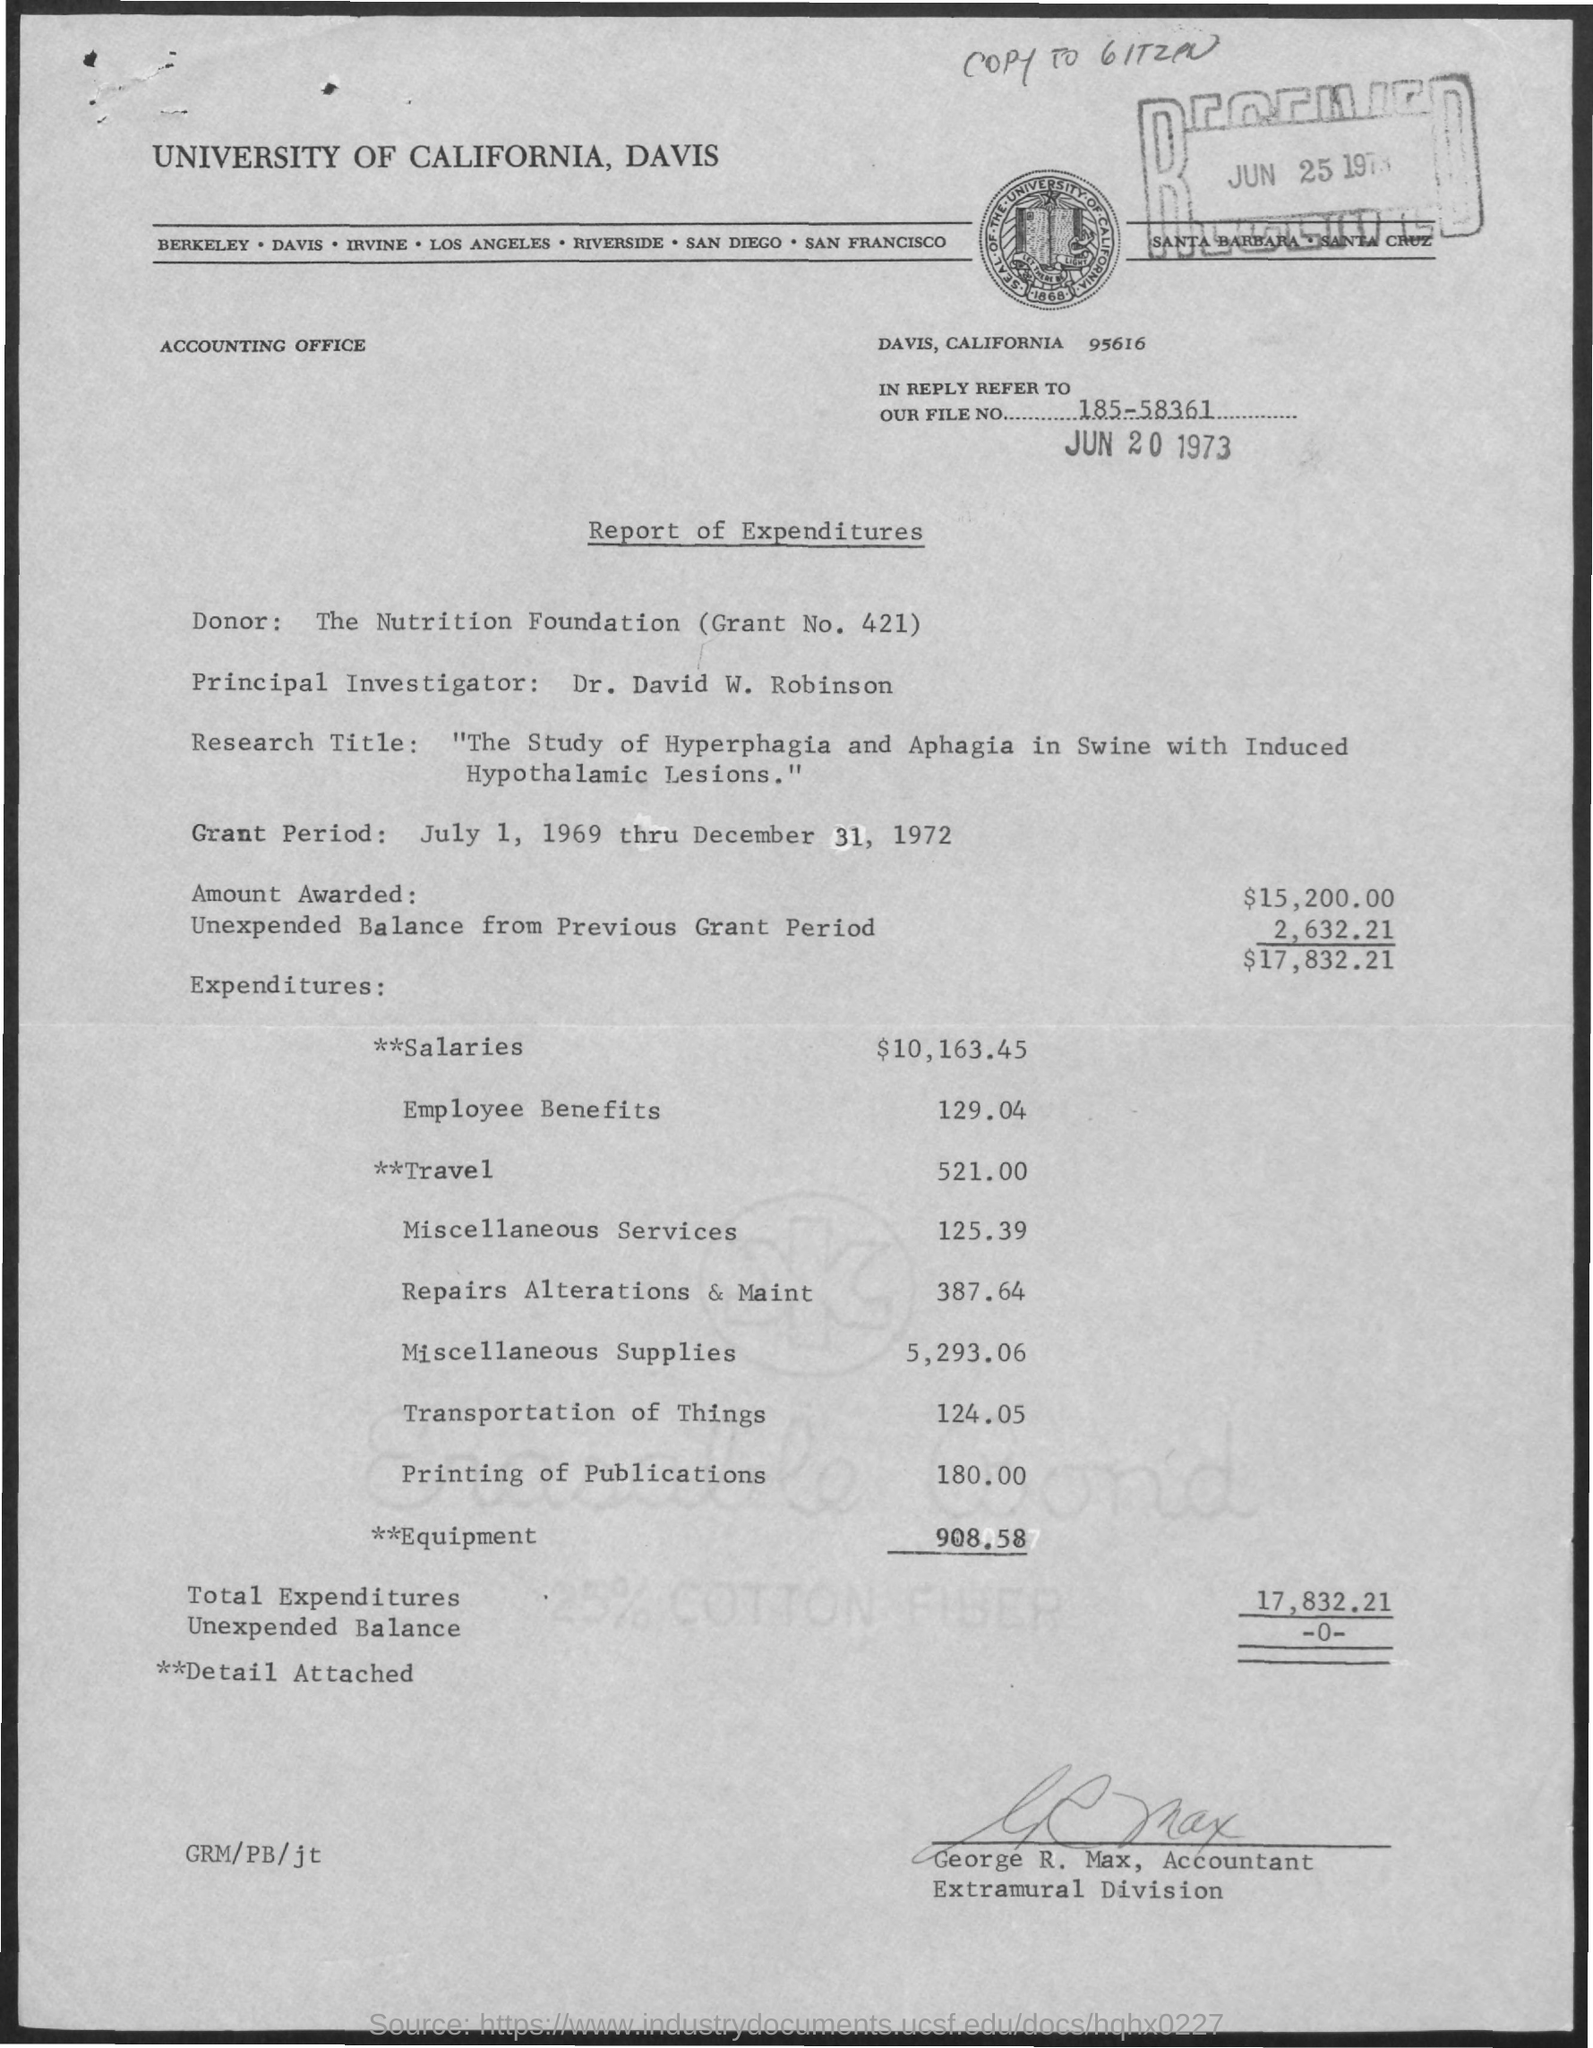Highlight a few significant elements in this photo. The unexpended balance is the amount remaining after all disbursements have been made from a fund or account. In the given example, the unexpended balance is shown as "-0-.." which means that there is no balance remaining. The title of the document is 'Report of Expenditures.' The principal investigator is Dr. David W. Robinson. The total expenditures are 17,832.21. The Nutrition Foundation is the donor for Grant No. 421. 